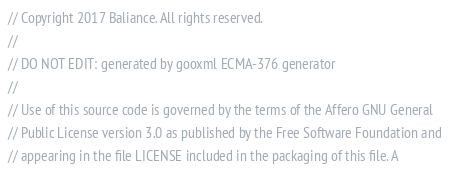Convert code to text. <code><loc_0><loc_0><loc_500><loc_500><_Go_>// Copyright 2017 Baliance. All rights reserved.
//
// DO NOT EDIT: generated by gooxml ECMA-376 generator
//
// Use of this source code is governed by the terms of the Affero GNU General
// Public License version 3.0 as published by the Free Software Foundation and
// appearing in the file LICENSE included in the packaging of this file. A</code> 